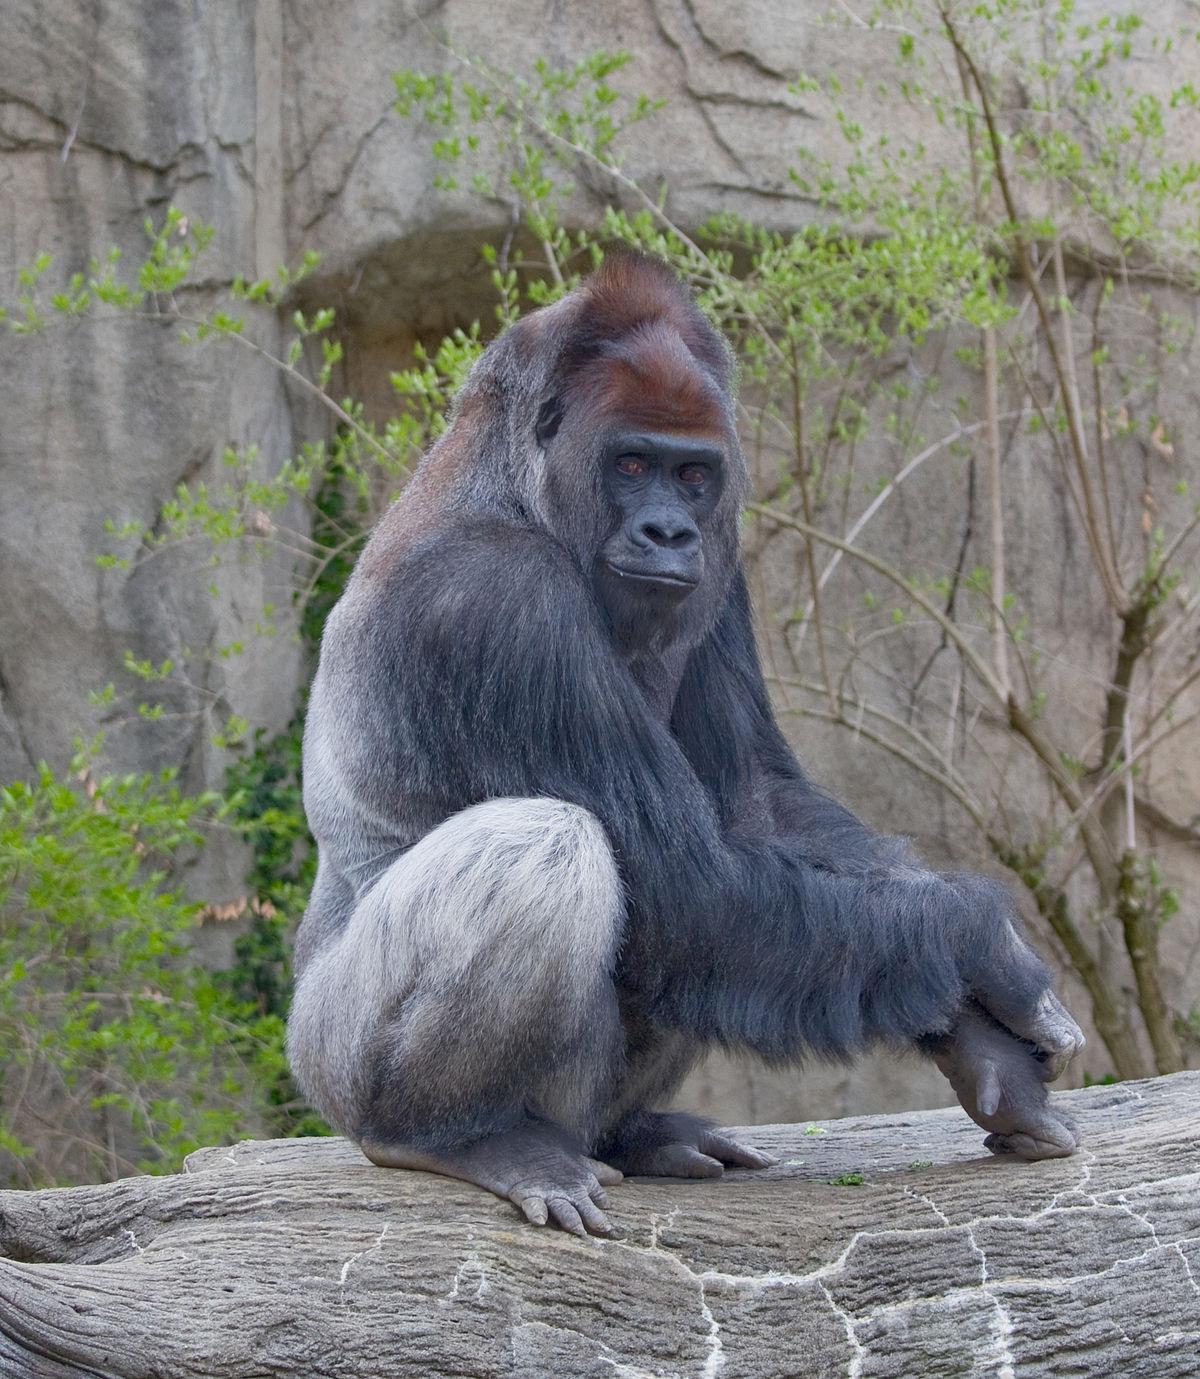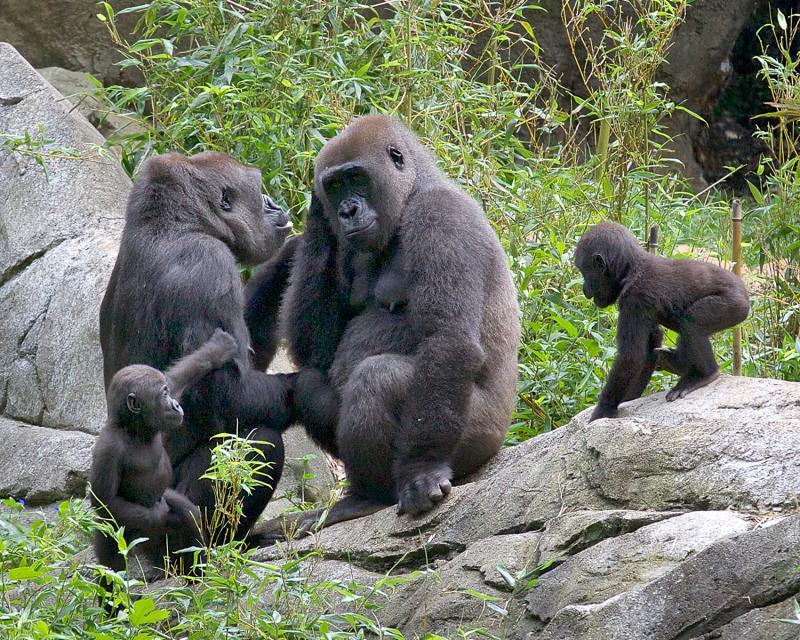The first image is the image on the left, the second image is the image on the right. Assess this claim about the two images: "A baby gorilla is holding onto an adult in an image with only two gorillas.". Correct or not? Answer yes or no. No. 